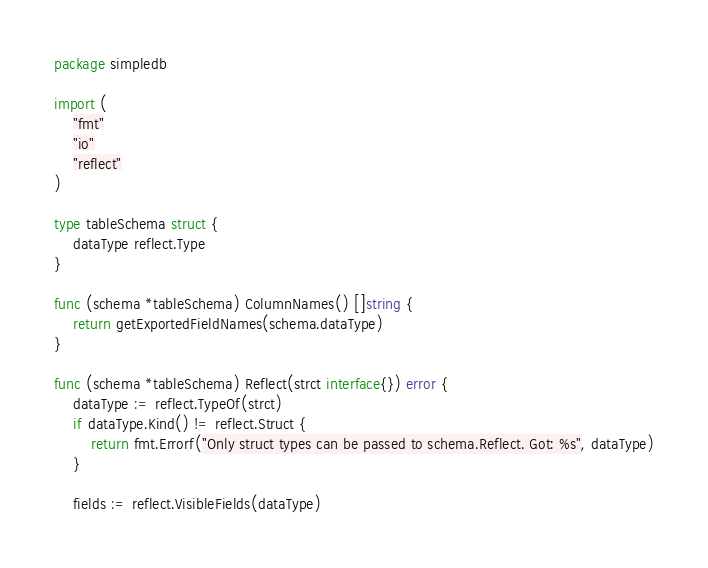<code> <loc_0><loc_0><loc_500><loc_500><_Go_>package simpledb

import (
	"fmt"
	"io"
	"reflect"
)

type tableSchema struct {
	dataType reflect.Type
}

func (schema *tableSchema) ColumnNames() []string {
	return getExportedFieldNames(schema.dataType)
}

func (schema *tableSchema) Reflect(strct interface{}) error {
	dataType := reflect.TypeOf(strct)
	if dataType.Kind() != reflect.Struct {
		return fmt.Errorf("Only struct types can be passed to schema.Reflect. Got: %s", dataType)
	}

	fields := reflect.VisibleFields(dataType)
</code> 